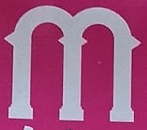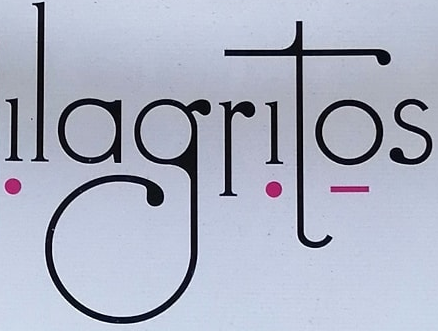What text is displayed in these images sequentially, separated by a semicolon? m; ǃlagrǃtọs 